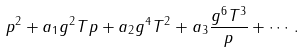Convert formula to latex. <formula><loc_0><loc_0><loc_500><loc_500>p ^ { 2 } + a _ { 1 } g ^ { 2 } T p + a _ { 2 } g ^ { 4 } T ^ { 2 } + a _ { 3 } \frac { g ^ { 6 } T ^ { 3 } } { p } + \cdots .</formula> 